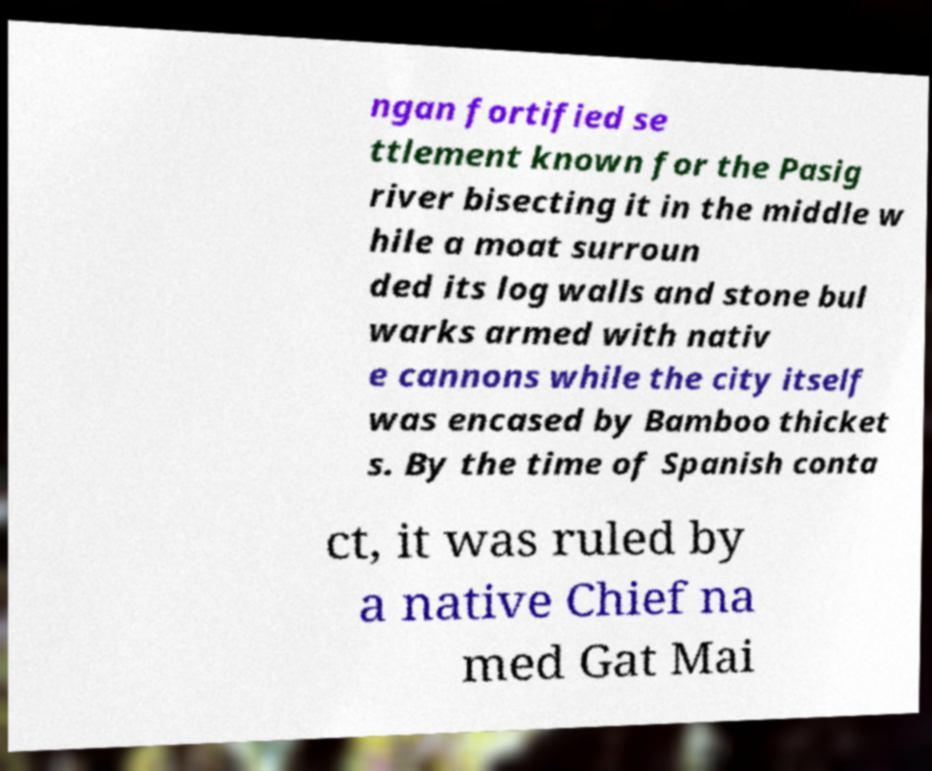Please identify and transcribe the text found in this image. ngan fortified se ttlement known for the Pasig river bisecting it in the middle w hile a moat surroun ded its log walls and stone bul warks armed with nativ e cannons while the city itself was encased by Bamboo thicket s. By the time of Spanish conta ct, it was ruled by a native Chief na med Gat Mai 